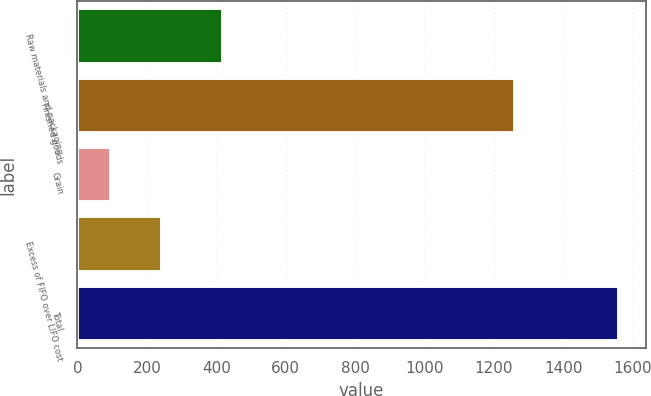Convert chart. <chart><loc_0><loc_0><loc_500><loc_500><bar_chart><fcel>Raw materials and packaging<fcel>Finished goods<fcel>Grain<fcel>Excess of FIFO over LIFO cost<fcel>Total<nl><fcel>419<fcel>1260.2<fcel>97.1<fcel>243.33<fcel>1559.4<nl></chart> 